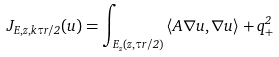Convert formula to latex. <formula><loc_0><loc_0><loc_500><loc_500>J _ { E , z , k \tau r / 2 } ( u ) = \int _ { E _ { z } ( z , \tau r / 2 ) } \left \langle A \nabla u , \nabla u \right \rangle + q ^ { 2 } _ { + }</formula> 